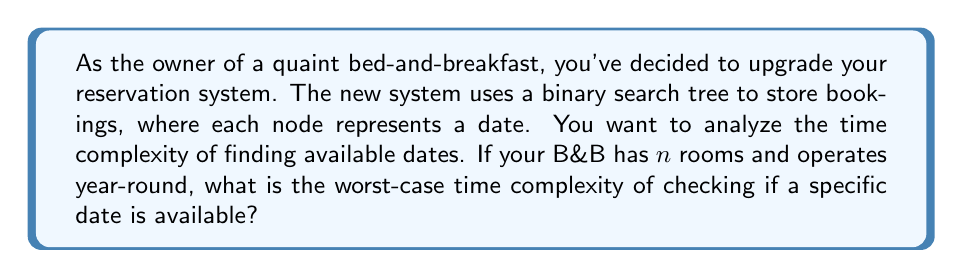Can you solve this math problem? Let's break this down step-by-step:

1) First, we need to understand the data structure being used. It's a binary search tree (BST) where each node represents a date.

2) In a BST, the worst-case time complexity for searching is $O(\log n)$, where $n$ is the number of nodes. This occurs when the tree is balanced.

3) However, in this case, we're not searching for a specific date. We're checking if a date is available, which means we need to find the date and then check if all rooms are booked for that date.

4) Finding the date in the BST takes $O(\log d)$ time, where $d$ is the number of days in a year (365 or 366).

5) Once we find the date, we need to check if all rooms are booked. This is a constant time operation, $O(1)$, as we're just comparing the number of bookings to the total number of rooms.

6) Therefore, the overall time complexity is $O(\log d + 1)$, which simplifies to $O(\log d)$.

7) It's important to note that $d$ is constant (365 or 366), so we could argue that the time complexity is actually $O(1)$. However, for the purpose of this analysis, we'll keep it as $O(\log d)$ to show the relationship with the number of days.

8) The number of rooms $n$ doesn't affect the time complexity in this case, as we're only checking availability for a single date.
Answer: $O(\log d)$, where $d$ is the number of days in a year. 